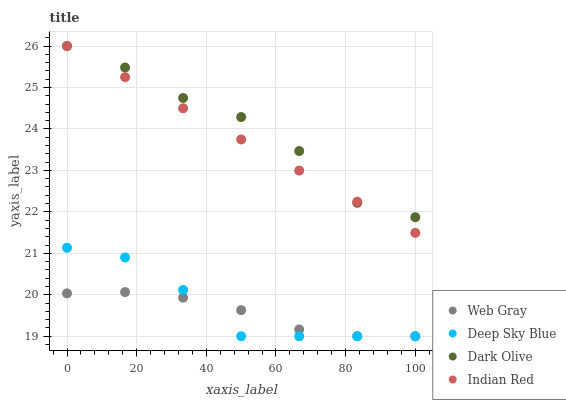Does Web Gray have the minimum area under the curve?
Answer yes or no. Yes. Does Dark Olive have the maximum area under the curve?
Answer yes or no. Yes. Does Indian Red have the minimum area under the curve?
Answer yes or no. No. Does Indian Red have the maximum area under the curve?
Answer yes or no. No. Is Indian Red the smoothest?
Answer yes or no. Yes. Is Dark Olive the roughest?
Answer yes or no. Yes. Is Web Gray the smoothest?
Answer yes or no. No. Is Web Gray the roughest?
Answer yes or no. No. Does Web Gray have the lowest value?
Answer yes or no. Yes. Does Indian Red have the lowest value?
Answer yes or no. No. Does Indian Red have the highest value?
Answer yes or no. Yes. Does Web Gray have the highest value?
Answer yes or no. No. Is Deep Sky Blue less than Indian Red?
Answer yes or no. Yes. Is Indian Red greater than Web Gray?
Answer yes or no. Yes. Does Indian Red intersect Dark Olive?
Answer yes or no. Yes. Is Indian Red less than Dark Olive?
Answer yes or no. No. Is Indian Red greater than Dark Olive?
Answer yes or no. No. Does Deep Sky Blue intersect Indian Red?
Answer yes or no. No. 